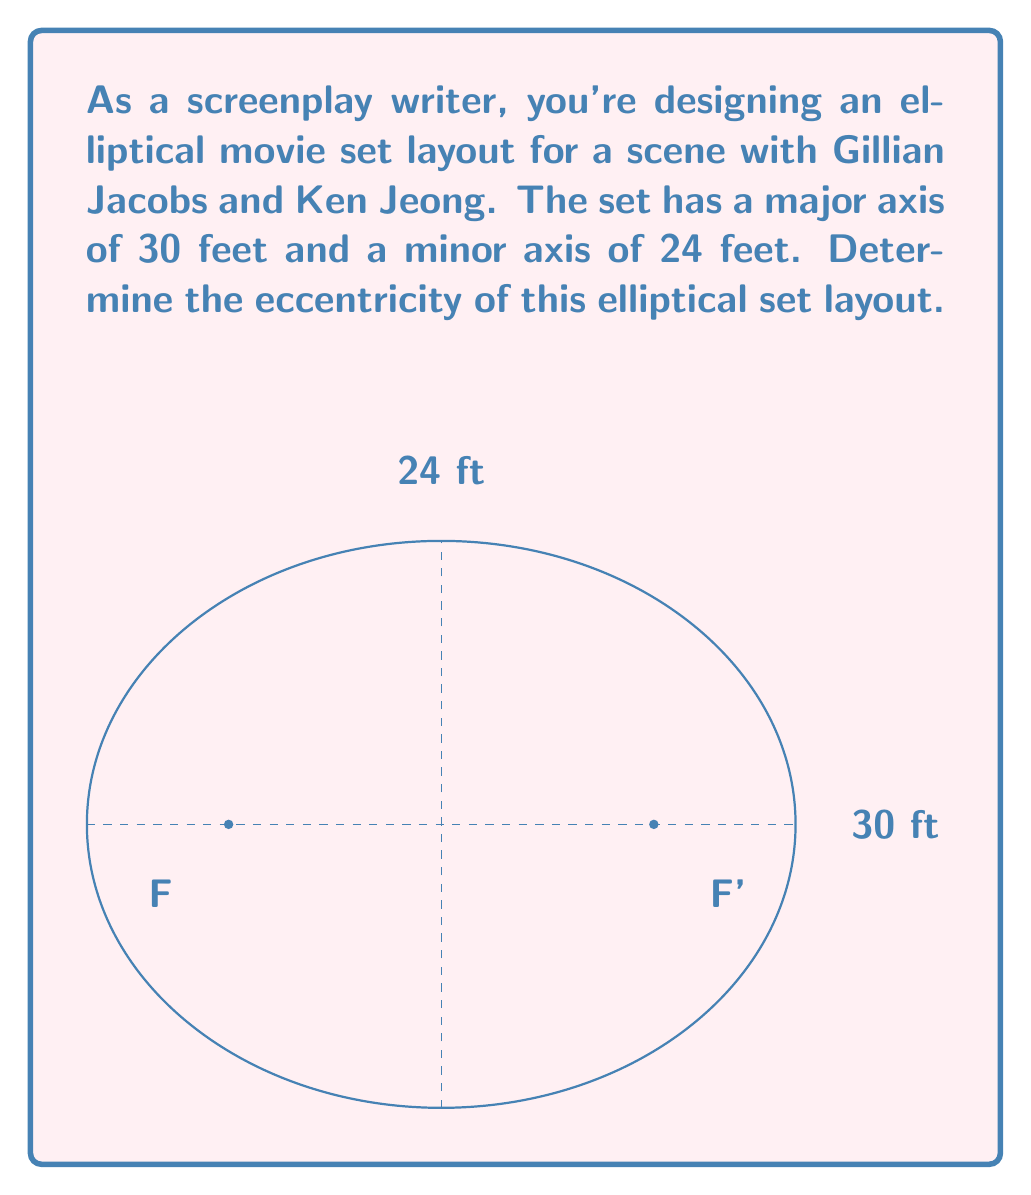Provide a solution to this math problem. Let's approach this step-by-step:

1) The eccentricity of an ellipse is defined as:

   $$e = \frac{c}{a}$$

   where $c$ is the distance from the center to a focus, and $a$ is the length of the semi-major axis.

2) We're given the major axis (30 feet) and minor axis (24 feet). Let's define:
   
   $a = 15$ (half of the major axis)
   $b = 12$ (half of the minor axis)

3) In an ellipse, $a$, $b$, and $c$ are related by the equation:

   $$a^2 = b^2 + c^2$$

4) We can solve for $c$:

   $$c^2 = a^2 - b^2$$
   $$c^2 = 15^2 - 12^2 = 225 - 144 = 81$$
   $$c = \sqrt{81} = 9$$

5) Now we can calculate the eccentricity:

   $$e = \frac{c}{a} = \frac{9}{15} = \frac{3}{5} = 0.6$$

Therefore, the eccentricity of the elliptical set layout is 0.6.
Answer: $\frac{3}{5}$ or $0.6$ 